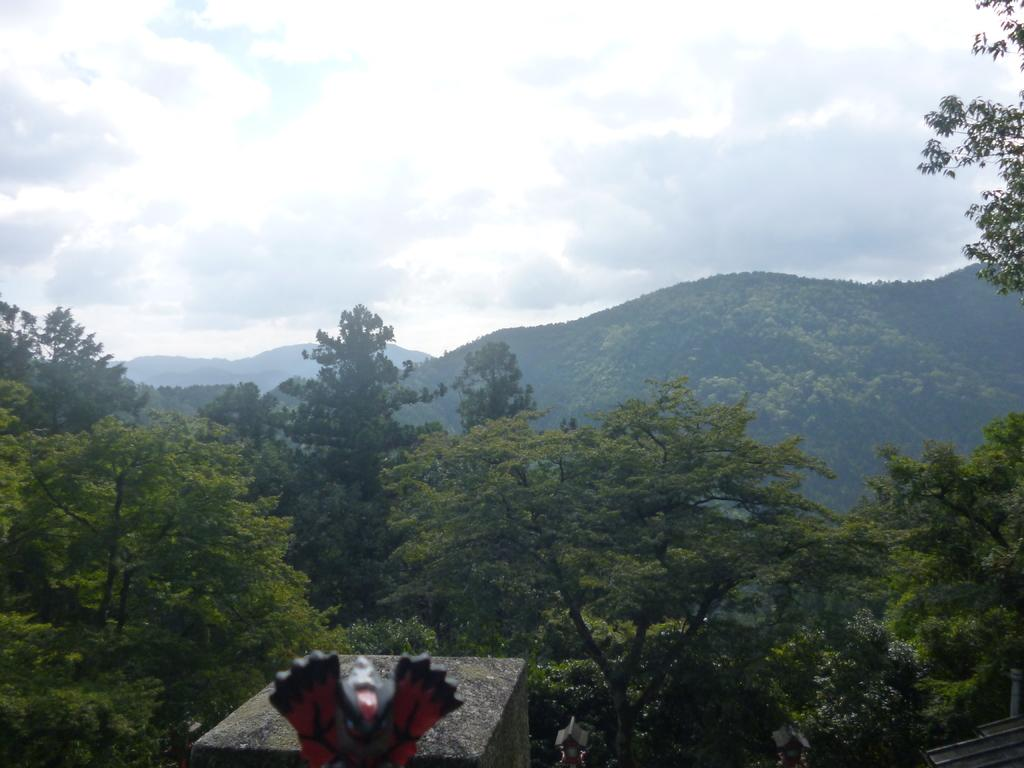What is the main subject of the image? There is a sculpture in the image. What other objects or features can be seen in the image? There is a stone, trees, mountains, and the sky visible in the image. Can you describe the natural environment in the image? The image features trees and mountains, which are part of the natural environment. What is visible in the background of the image? The sky is visible in the background of the image. What type of mint is growing near the sculpture in the image? There is: There is no mint plant visible in the image; the image features trees and mountains as part of the natural environment. 